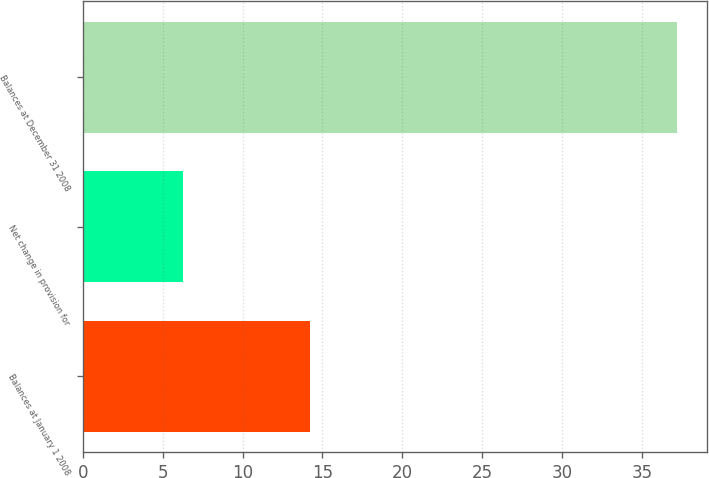Convert chart to OTSL. <chart><loc_0><loc_0><loc_500><loc_500><bar_chart><fcel>Balances at January 1 2008<fcel>Net change in provision for<fcel>Balances at December 31 2008<nl><fcel>14.2<fcel>6.3<fcel>37.2<nl></chart> 